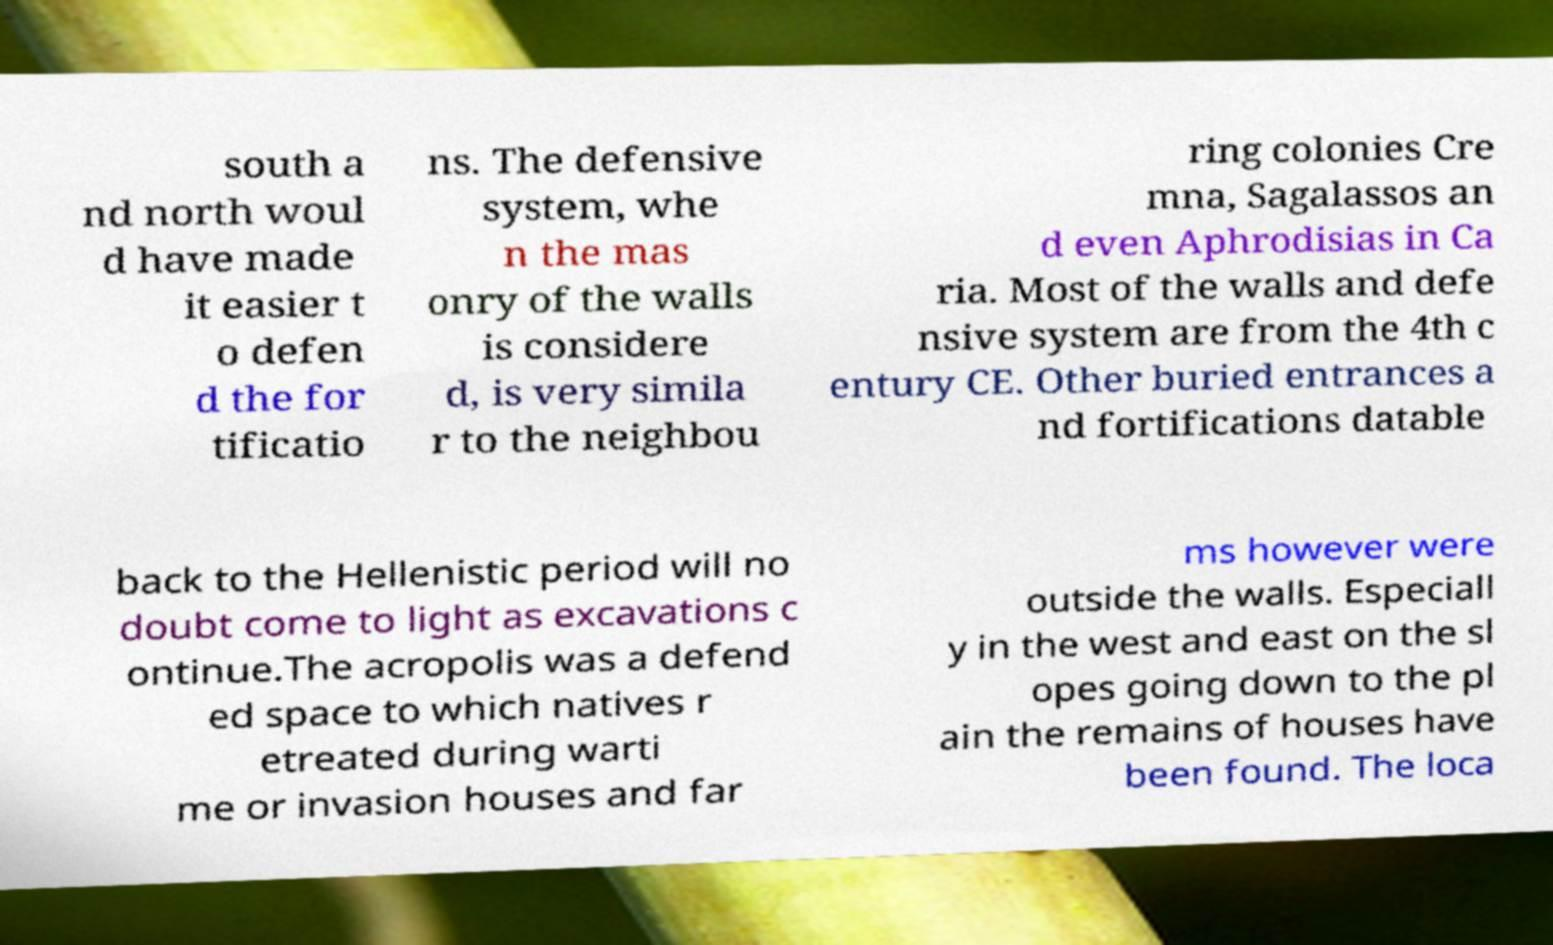Can you read and provide the text displayed in the image?This photo seems to have some interesting text. Can you extract and type it out for me? south a nd north woul d have made it easier t o defen d the for tificatio ns. The defensive system, whe n the mas onry of the walls is considere d, is very simila r to the neighbou ring colonies Cre mna, Sagalassos an d even Aphrodisias in Ca ria. Most of the walls and defe nsive system are from the 4th c entury CE. Other buried entrances a nd fortifications datable back to the Hellenistic period will no doubt come to light as excavations c ontinue.The acropolis was a defend ed space to which natives r etreated during warti me or invasion houses and far ms however were outside the walls. Especiall y in the west and east on the sl opes going down to the pl ain the remains of houses have been found. The loca 